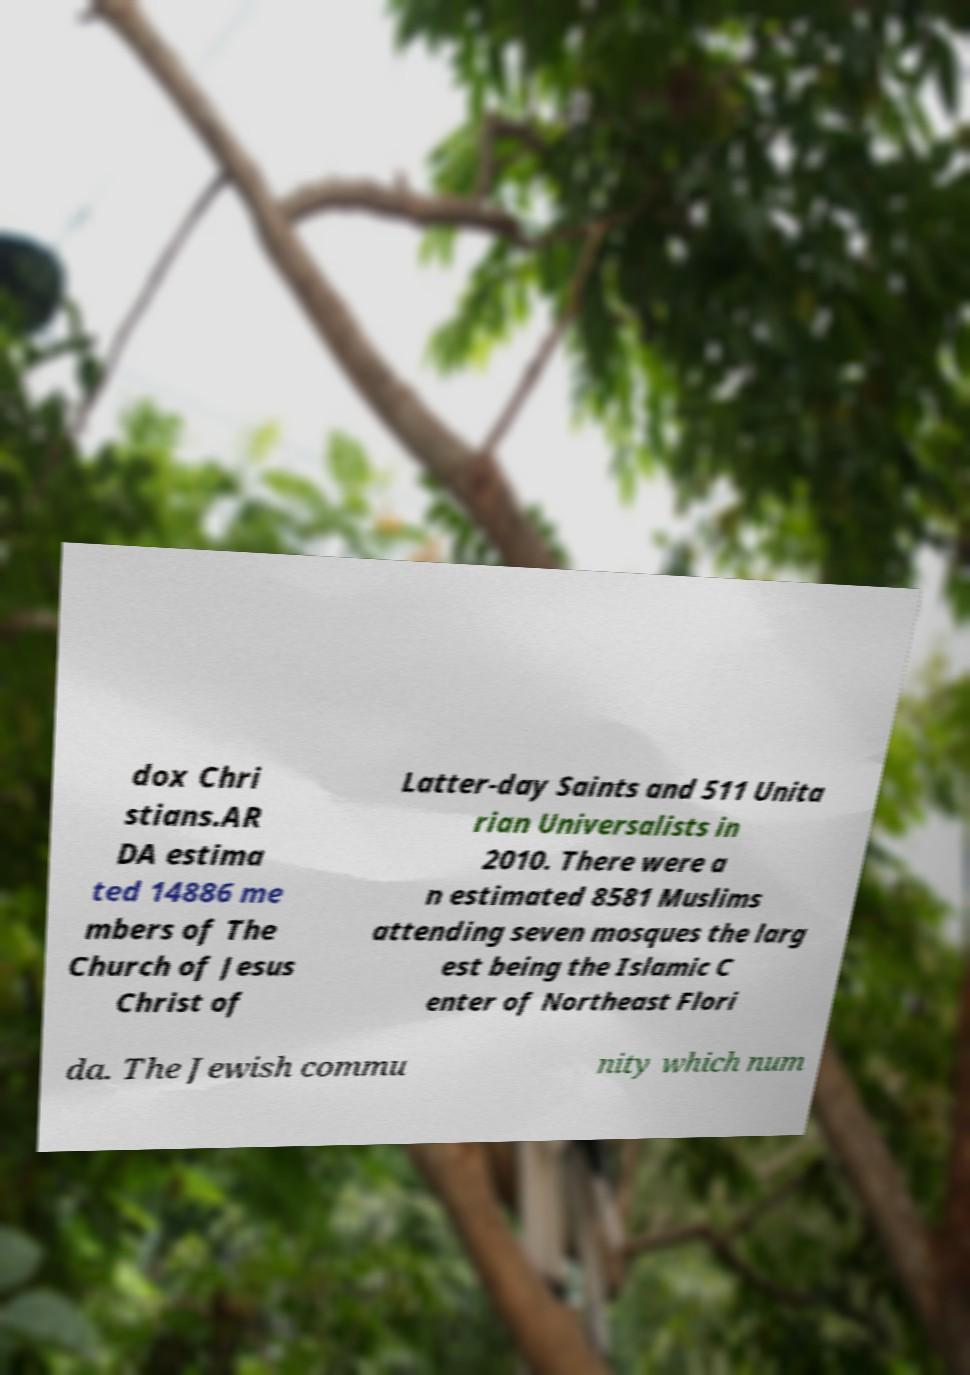For documentation purposes, I need the text within this image transcribed. Could you provide that? dox Chri stians.AR DA estima ted 14886 me mbers of The Church of Jesus Christ of Latter-day Saints and 511 Unita rian Universalists in 2010. There were a n estimated 8581 Muslims attending seven mosques the larg est being the Islamic C enter of Northeast Flori da. The Jewish commu nity which num 